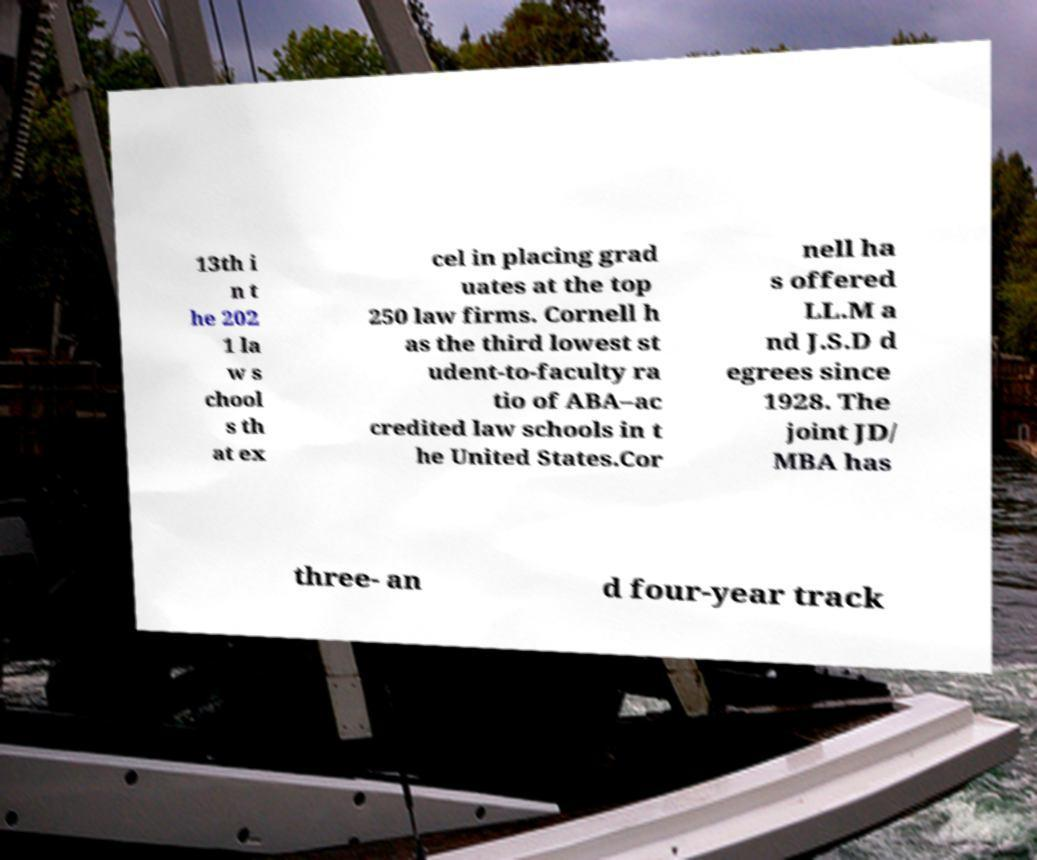There's text embedded in this image that I need extracted. Can you transcribe it verbatim? 13th i n t he 202 1 la w s chool s th at ex cel in placing grad uates at the top 250 law firms. Cornell h as the third lowest st udent-to-faculty ra tio of ABA–ac credited law schools in t he United States.Cor nell ha s offered LL.M a nd J.S.D d egrees since 1928. The joint JD/ MBA has three- an d four-year track 